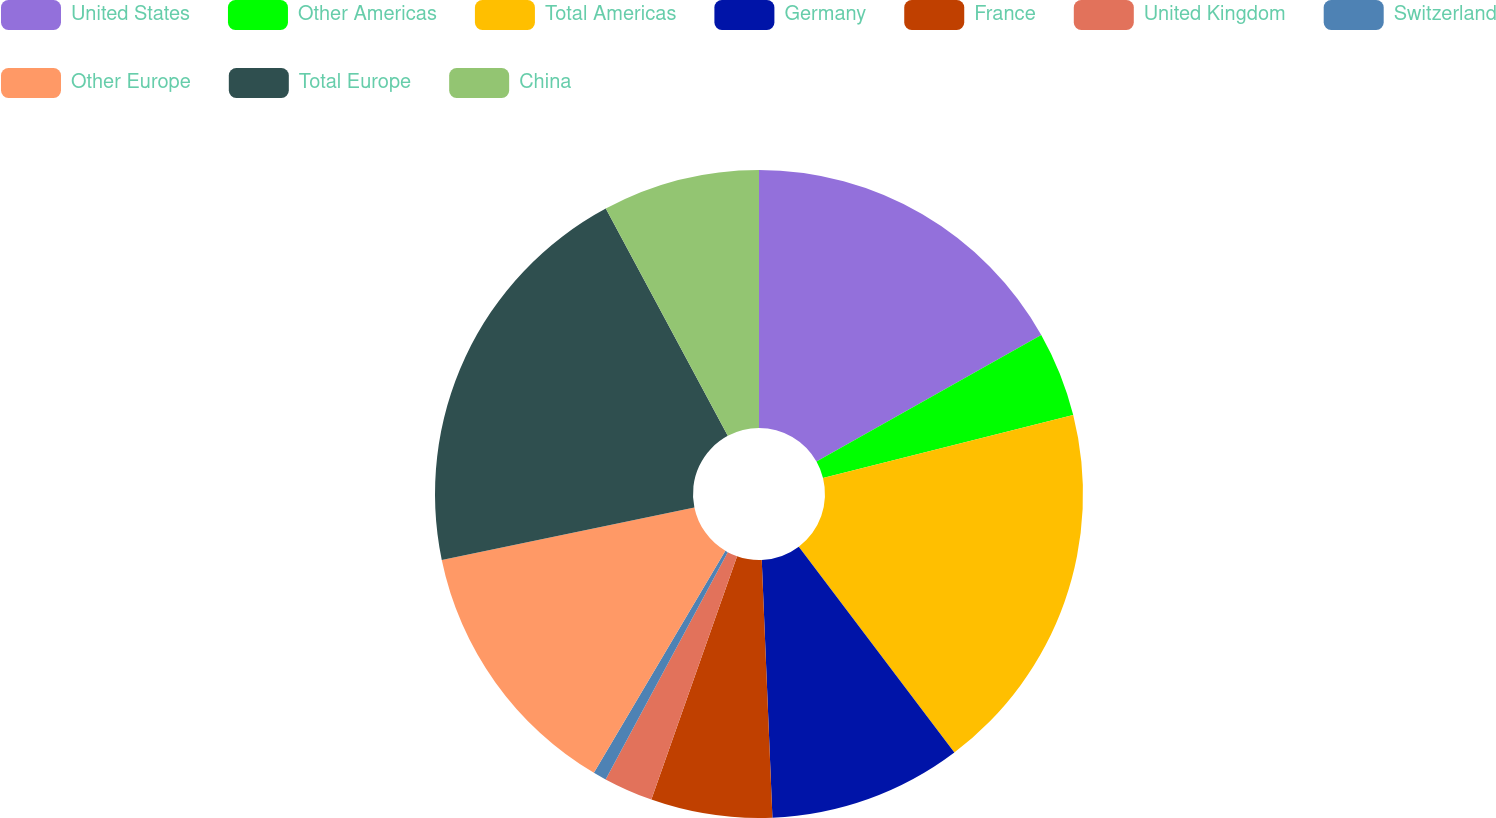Convert chart. <chart><loc_0><loc_0><loc_500><loc_500><pie_chart><fcel>United States<fcel>Other Americas<fcel>Total Americas<fcel>Germany<fcel>France<fcel>United Kingdom<fcel>Switzerland<fcel>Other Europe<fcel>Total Europe<fcel>China<nl><fcel>16.83%<fcel>4.25%<fcel>18.62%<fcel>9.64%<fcel>6.05%<fcel>2.46%<fcel>0.66%<fcel>13.23%<fcel>20.42%<fcel>7.84%<nl></chart> 